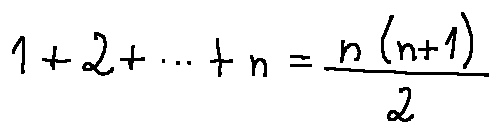Convert formula to latex. <formula><loc_0><loc_0><loc_500><loc_500>1 + 2 + \cdots + n = \frac { n ( n + 1 ) } { 2 }</formula> 